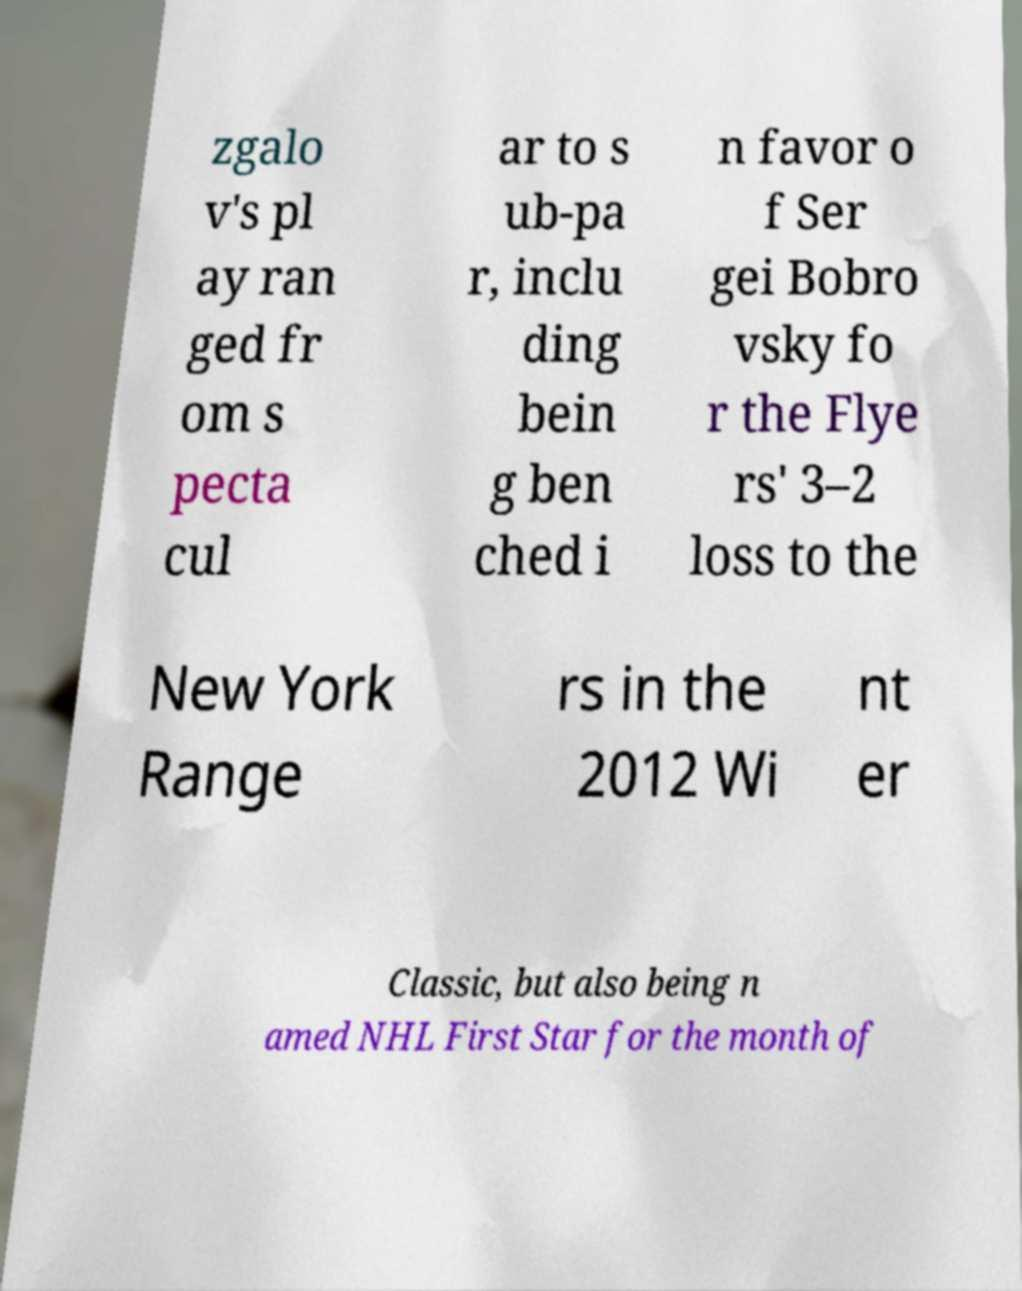I need the written content from this picture converted into text. Can you do that? zgalo v's pl ay ran ged fr om s pecta cul ar to s ub-pa r, inclu ding bein g ben ched i n favor o f Ser gei Bobro vsky fo r the Flye rs' 3–2 loss to the New York Range rs in the 2012 Wi nt er Classic, but also being n amed NHL First Star for the month of 